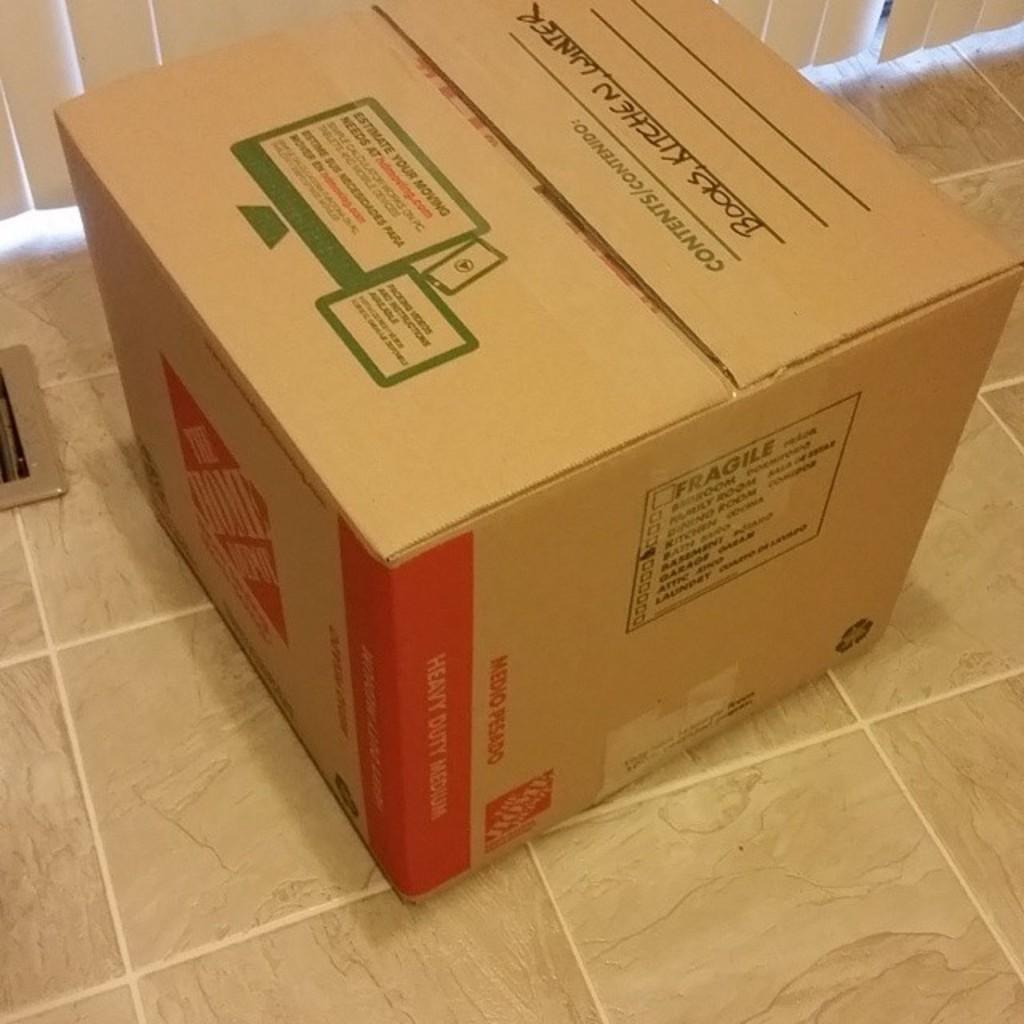<image>
Relay a brief, clear account of the picture shown. A box that shows books are being stored inside. 